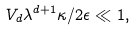<formula> <loc_0><loc_0><loc_500><loc_500>V _ { d } \lambda ^ { d + 1 } \kappa / 2 \epsilon \ll 1 ,</formula> 